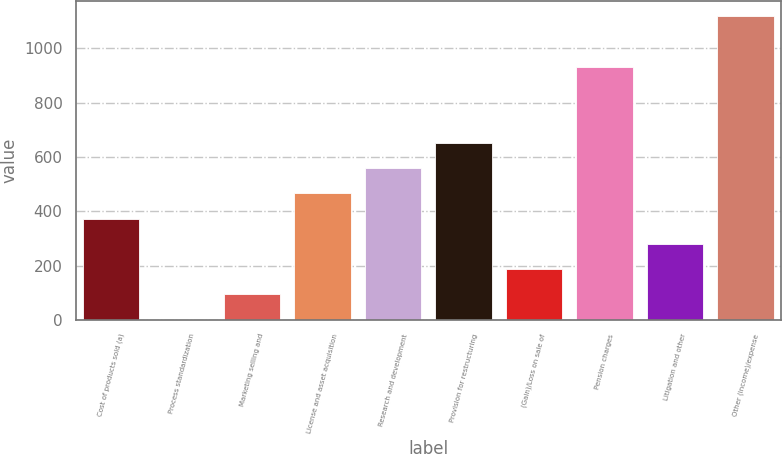<chart> <loc_0><loc_0><loc_500><loc_500><bar_chart><fcel>Cost of products sold (a)<fcel>Process standardization<fcel>Marketing selling and<fcel>License and asset acquisition<fcel>Research and development<fcel>Provision for restructuring<fcel>(Gain)/Loss on sale of<fcel>Pension charges<fcel>Litigation and other<fcel>Other (income)/expense<nl><fcel>373.4<fcel>1<fcel>94.1<fcel>466.5<fcel>559.6<fcel>652.7<fcel>187.2<fcel>932<fcel>280.3<fcel>1118.2<nl></chart> 